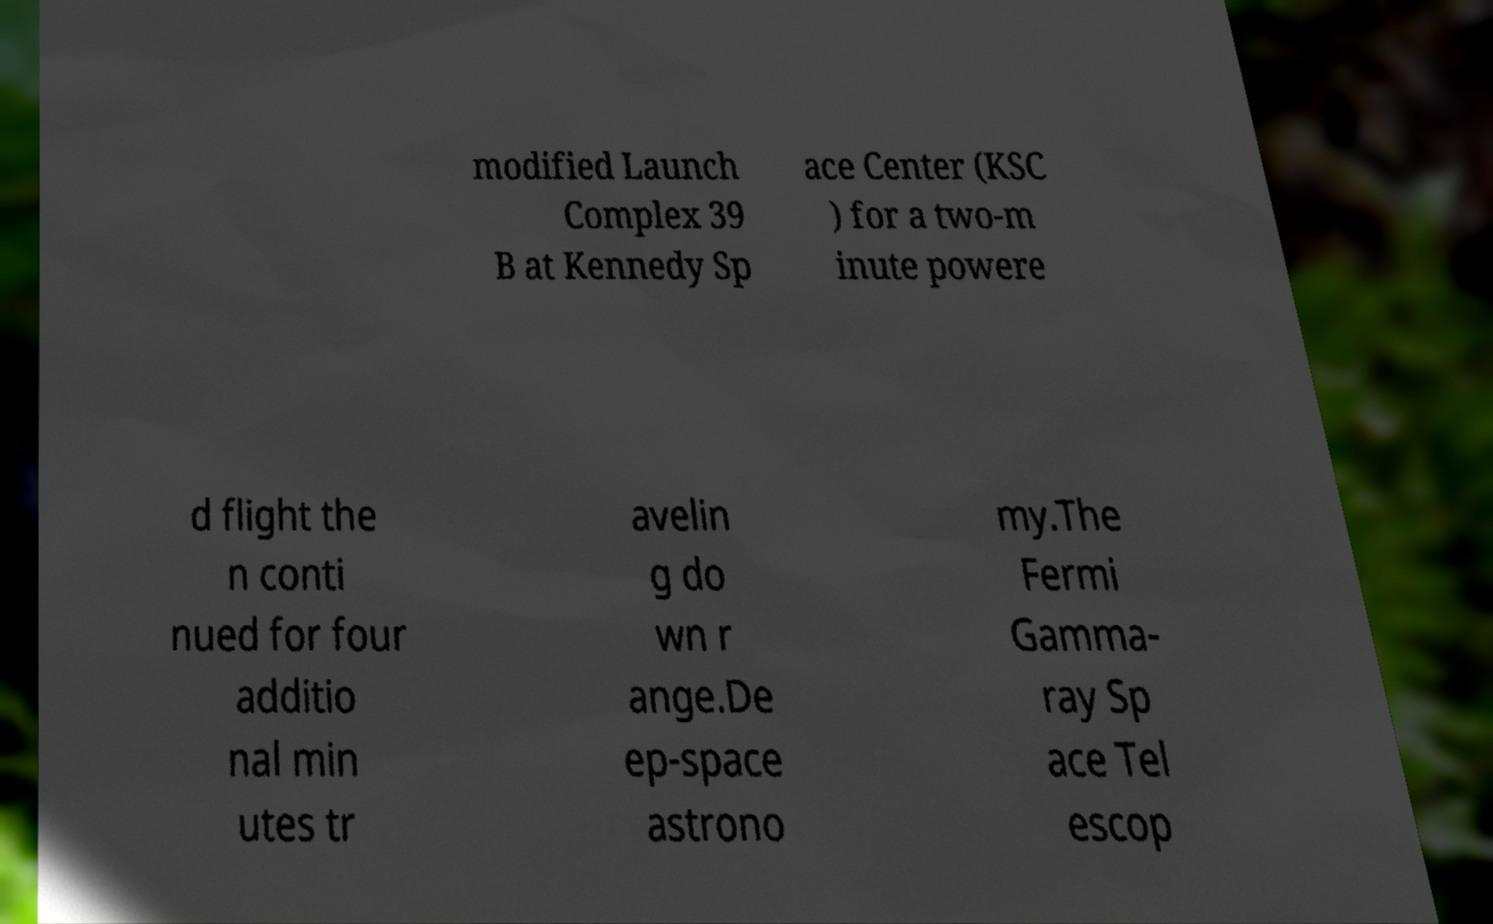Please identify and transcribe the text found in this image. modified Launch Complex 39 B at Kennedy Sp ace Center (KSC ) for a two-m inute powere d flight the n conti nued for four additio nal min utes tr avelin g do wn r ange.De ep-space astrono my.The Fermi Gamma- ray Sp ace Tel escop 